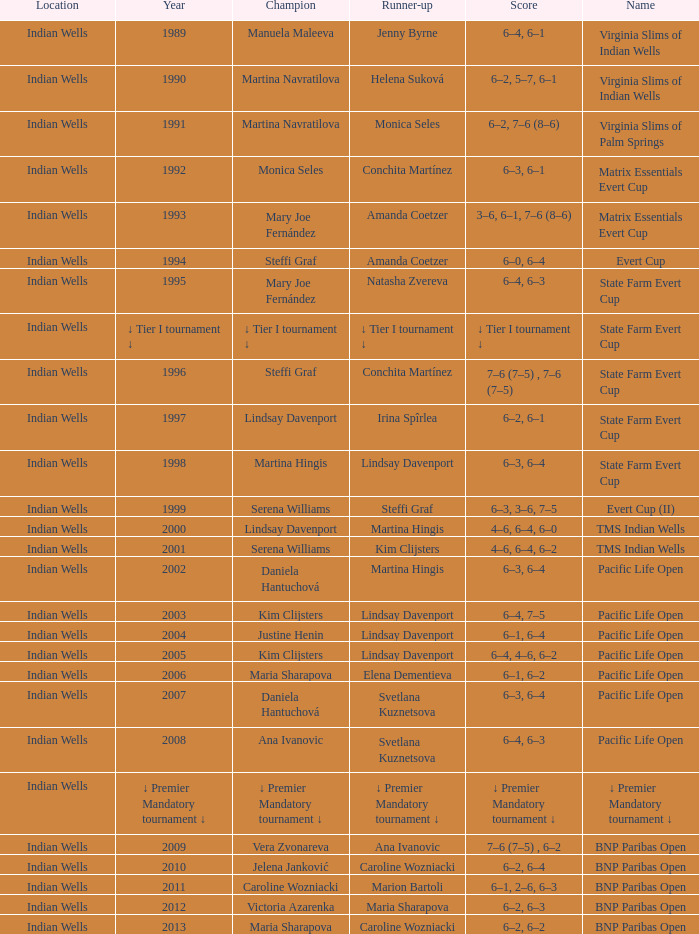Who secured the second place in the 2006 pacific life open? Elena Dementieva. 